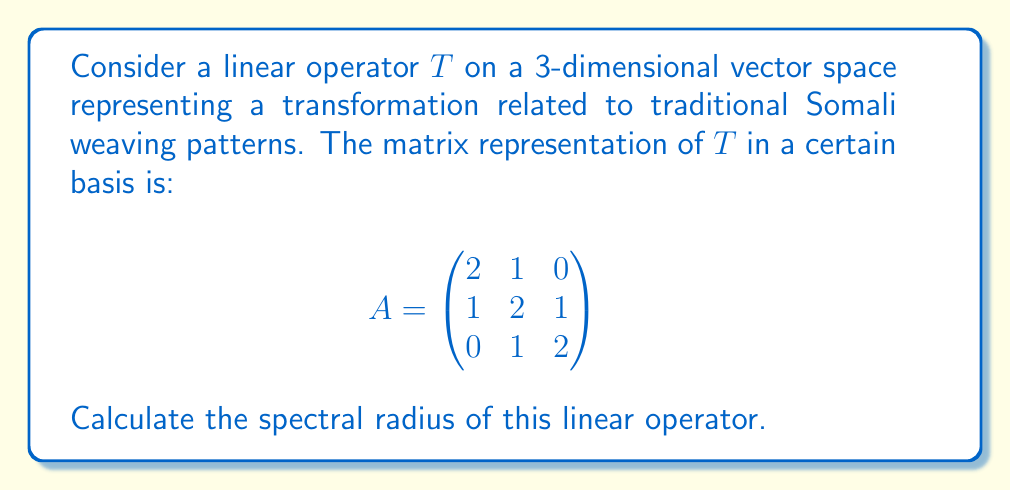Can you answer this question? To find the spectral radius of the linear operator $T$, we need to follow these steps:

1) First, we need to find the eigenvalues of the matrix $A$. The characteristic equation is:

   $$\det(A - \lambda I) = \begin{vmatrix}
   2-\lambda & 1 & 0 \\
   1 & 2-\lambda & 1 \\
   0 & 1 & 2-\lambda
   \end{vmatrix} = 0$$

2) Expanding this determinant:
   
   $(2-\lambda)[(2-\lambda)^2 - 1] - 1(1-0) = 0$
   
   $(2-\lambda)[(4-4\lambda+\lambda^2) - 1] - 1 = 0$
   
   $(2-\lambda)(3-4\lambda+\lambda^2) - 1 = 0$
   
   $6-8\lambda+2\lambda^2-3\lambda+4\lambda^2-\lambda^3 - 1 = 0$
   
   $-\lambda^3 + 6\lambda^2 - 11\lambda + 5 = 0$

3) This cubic equation can be factored as:

   $-(\lambda - 1)(\lambda - 2)(\lambda - 3) = 0$

4) So, the eigenvalues are $\lambda_1 = 1$, $\lambda_2 = 2$, and $\lambda_3 = 3$

5) The spectral radius is defined as the maximum of the absolute values of the eigenvalues:

   $\rho(T) = \max\{|\lambda_1|, |\lambda_2|, |\lambda_3|\}$

6) In this case, $\rho(T) = \max\{1, 2, 3\} = 3$
Answer: $3$ 